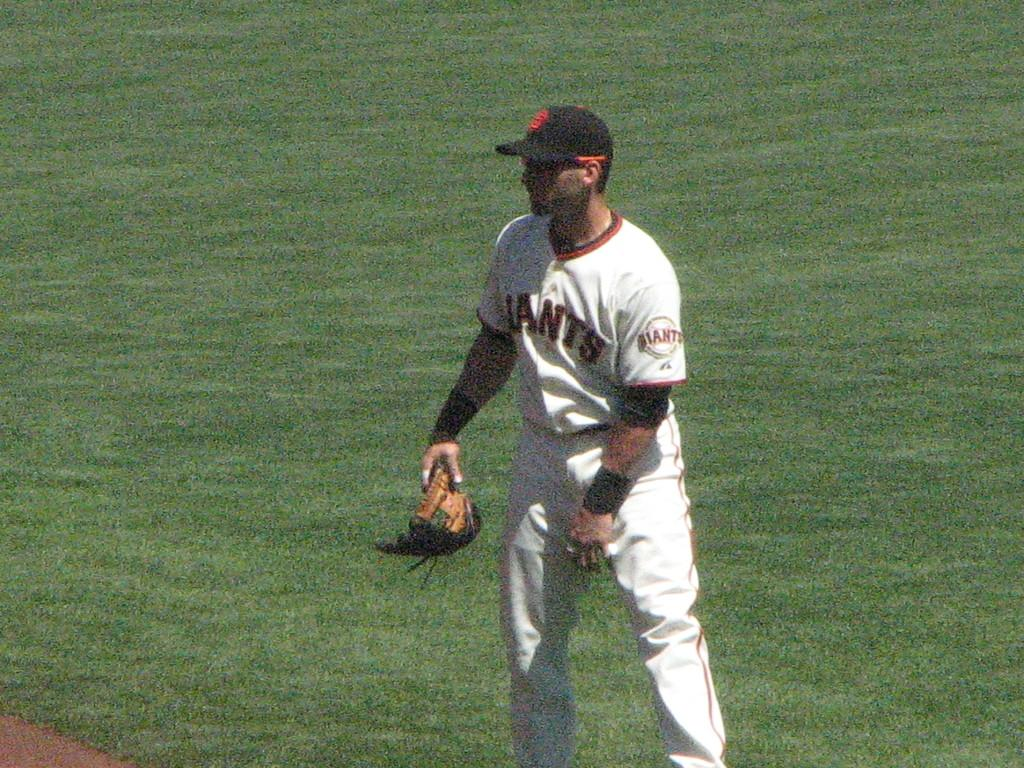<image>
Share a concise interpretation of the image provided. A man wearing a Giants baseball uniform holds his glove. 